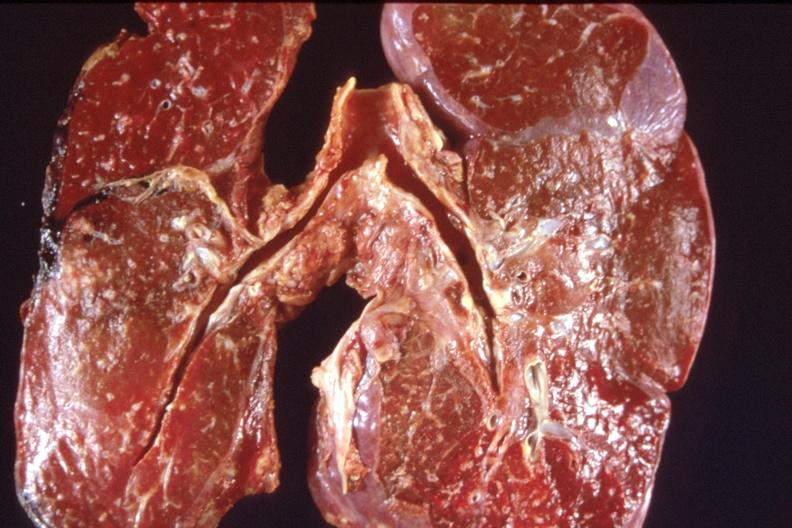what does this image show?
Answer the question using a single word or phrase. Lung 